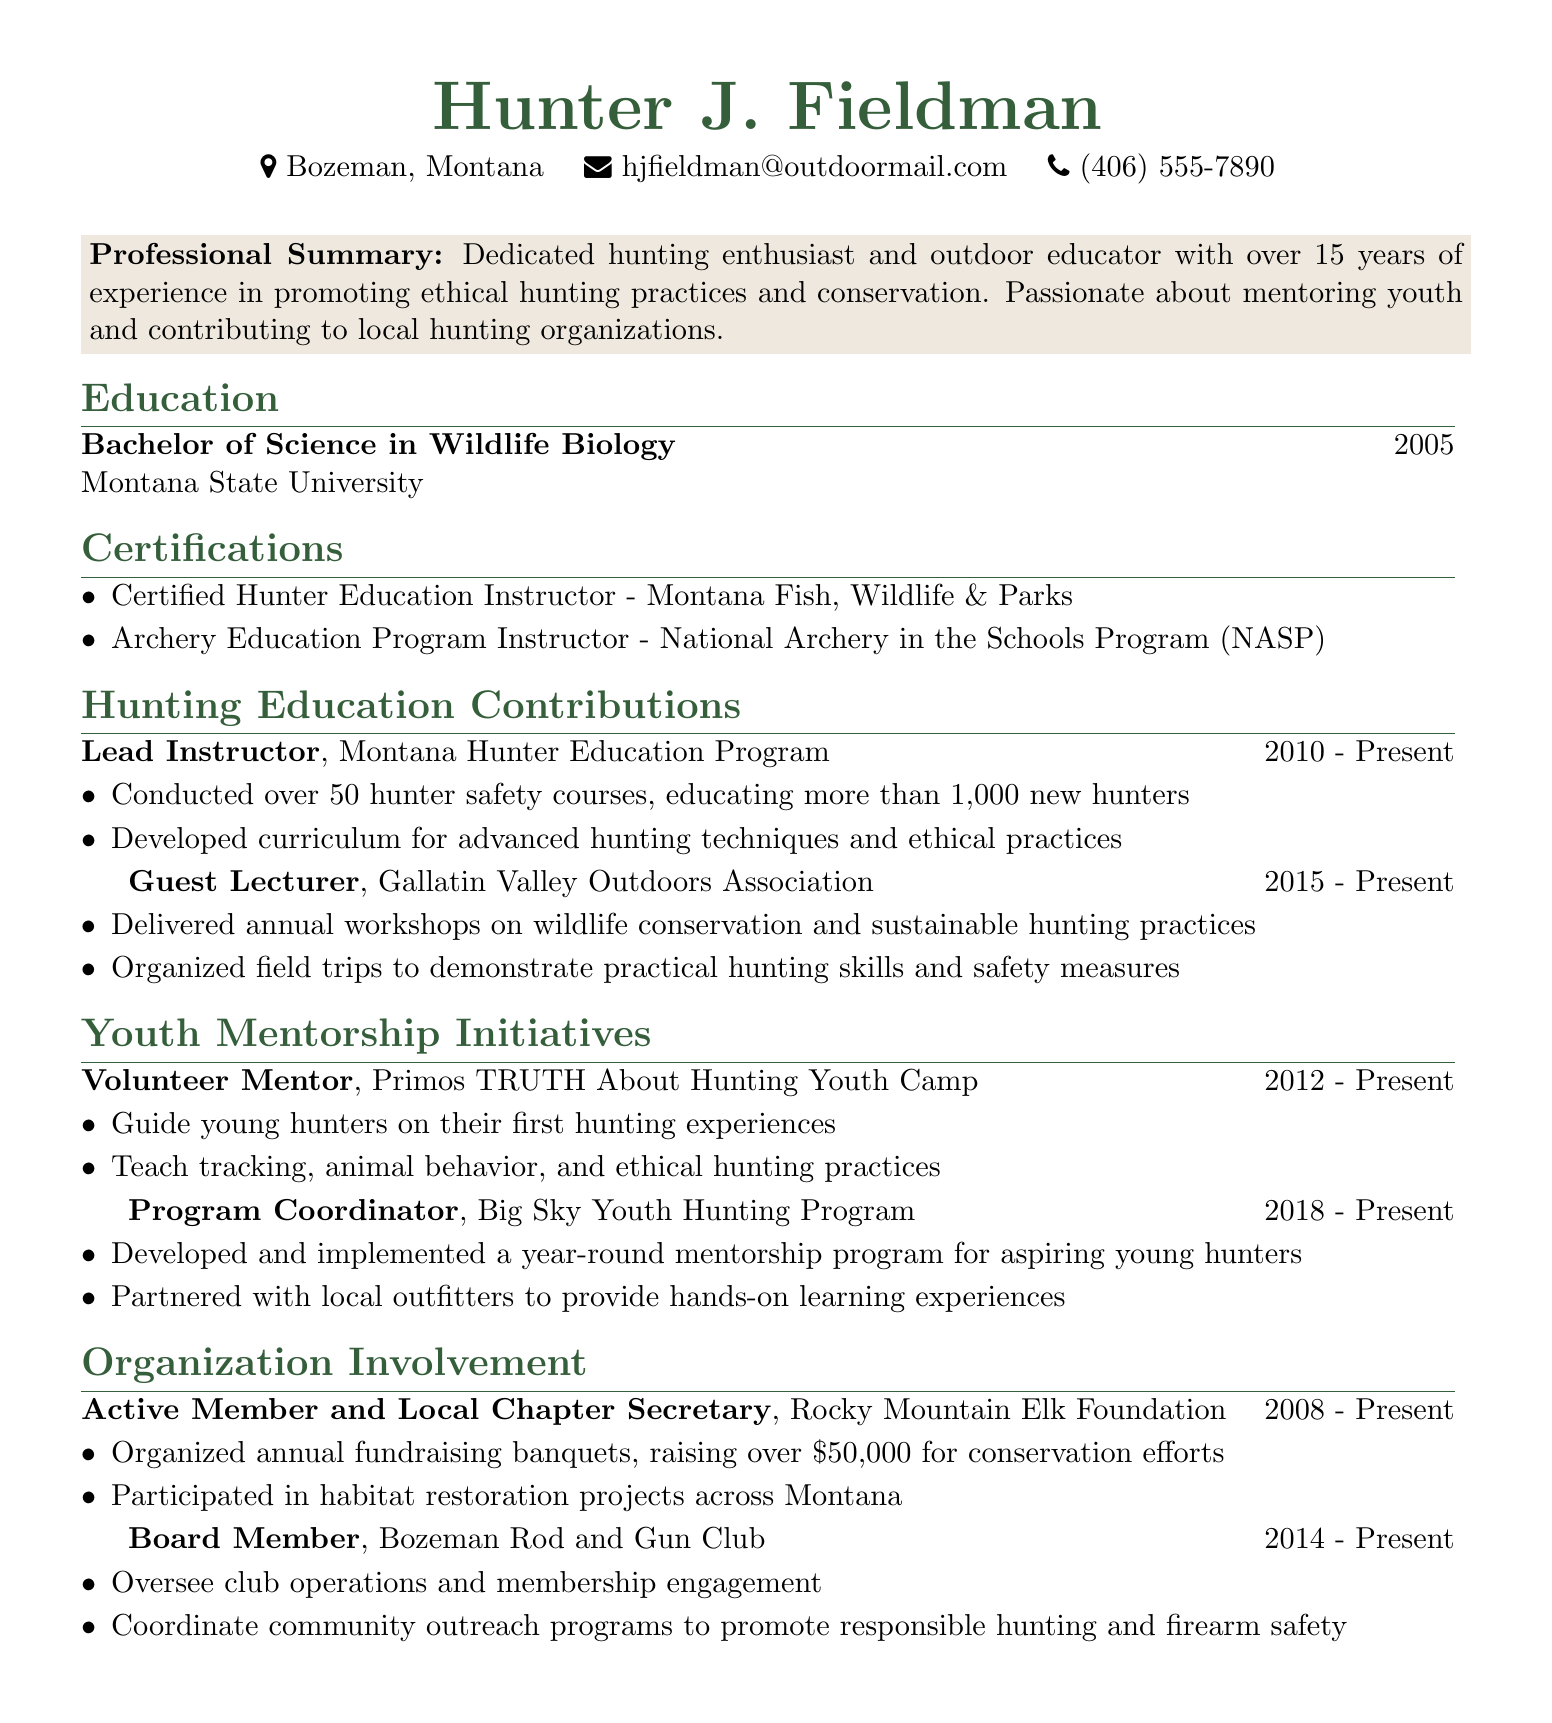what is the name of the individual? The name of the individual is prominently displayed at the top of the document.
Answer: Hunter J. Fieldman what is Hunter J. Fieldman’s location? The location is listed in the personal information section of the document.
Answer: Bozeman, Montana how many years of experience does Hunter J. Fieldman have? The professional summary mentions the number of years of experience.
Answer: over 15 years what degree did Hunter J. Fieldman earn? The education section specifies the degree obtained.
Answer: Bachelor of Science in Wildlife Biology how many youth mentorship initiatives has Hunter J. Fieldman participated in? The youth mentorship initiatives section lists two programs.
Answer: 2 what organization is Hunter J. Fieldman involved with as a board member? The organization section mentions the specific club.
Answer: Bozeman Rod and Gun Club what role does Hunter J. Fieldman hold in the Montana Hunter Education Program? The hunting education contributions section specifies the role.
Answer: Lead Instructor how much money has been raised for conservation efforts by the Rocky Mountain Elk Foundation events? The organization involvement section states the amount raised.
Answer: over $50,000 what is the certification that Hunter J. Fieldman holds related to archery? The certifications section lists a specific certification.
Answer: Archery Education Program Instructor - National Archery in the Schools Program (NASP) 